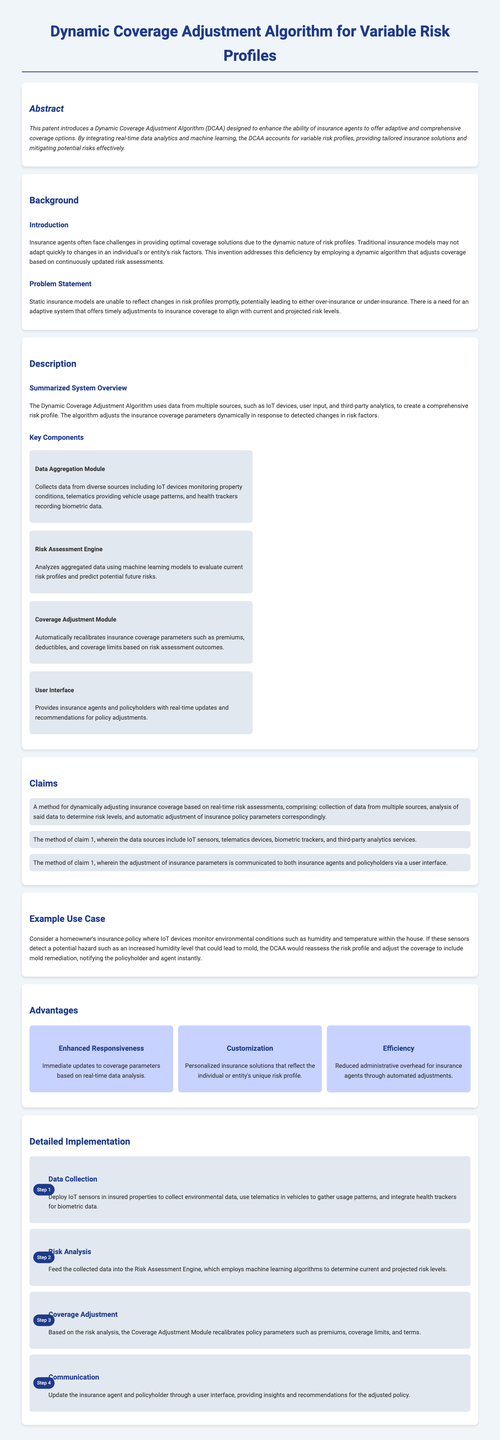What is the title of the patent? The title of the patent is found in the heading of the document, which introduces the subject matter being patented.
Answer: Dynamic Coverage Adjustment Algorithm for Variable Risk Profiles What is the primary benefit of the Dynamic Coverage Adjustment Algorithm? The abstract summarizes the innovative advantage, focusing on the improvement it offers to insurance agents.
Answer: Adaptive and comprehensive coverage options What is one key component mentioned in the document? The document describes various components of the system, specifying their functions.
Answer: Data Aggregation Module How many claims are listed in the patent document? The claims section outlines specific legal assertions made by the applicant; counting the items gives the total.
Answer: Three What type of data sources does the algorithm utilize? The document specifies the categories of data sources employed in the algorithm's operation for risk assessment.
Answer: IoT sensors, telematics devices, biometric trackers, and third-party analytics services What problem does the DCAA aim to address? The background information identifies the primary issue that the invention seeks to resolve in insurance modeling.
Answer: Static insurance models How does the system communicate adjustments to insurance agents? The document highlights the method of informing involved parties about adjustments made to policies.
Answer: User interface What is the third step in the detailed implementation? The detailed implementation section lists the sequential steps taken in the process, enabling understanding of the workflow.
Answer: Coverage Adjustment What is one advantage of the Dynamic Coverage Adjustment Algorithm? The advantages section enumerates benefits, emphasizing a particular strength of the system.
Answer: Enhanced Responsiveness 